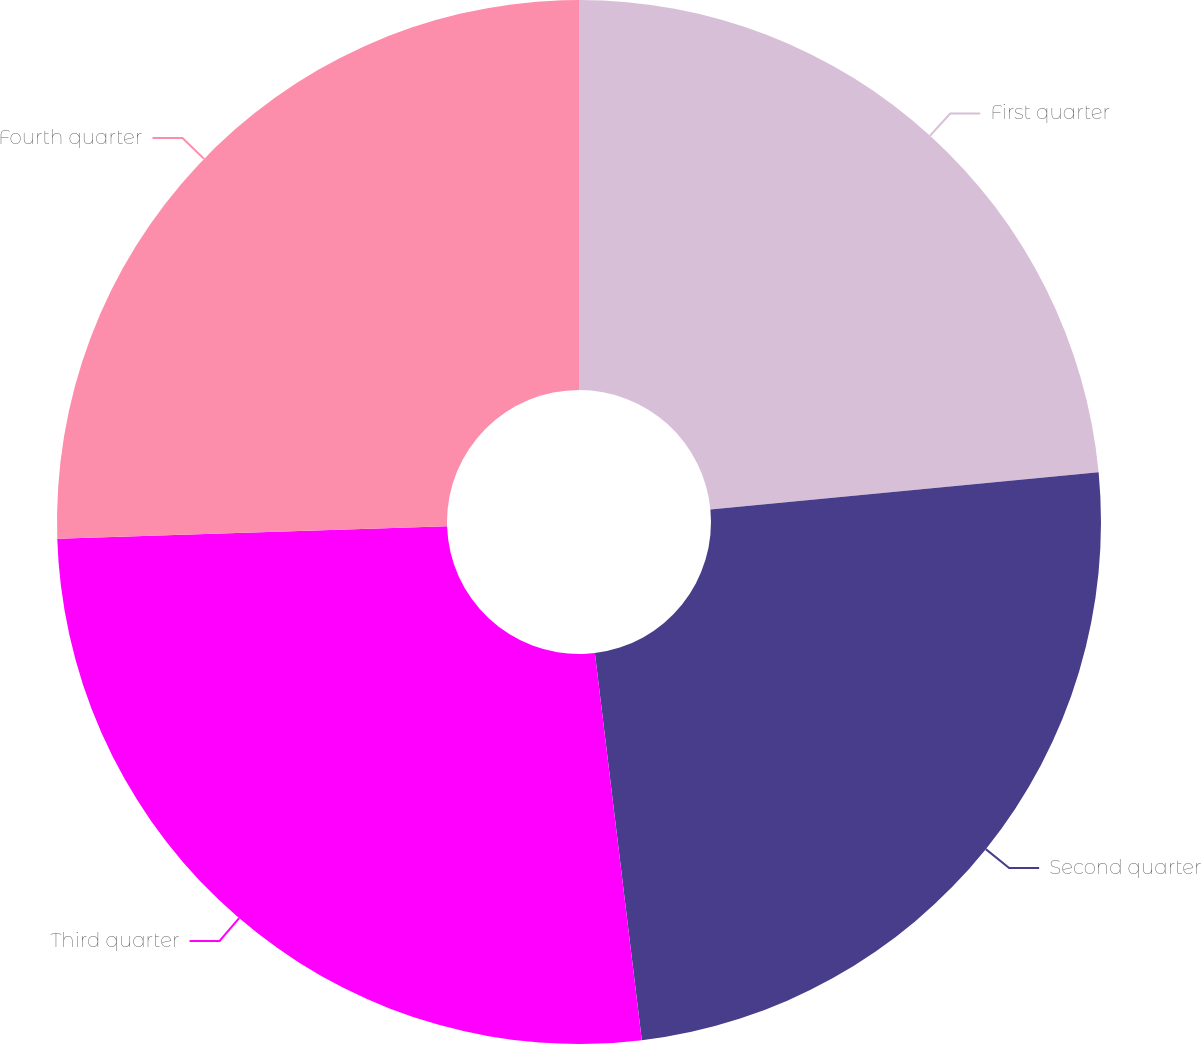Convert chart to OTSL. <chart><loc_0><loc_0><loc_500><loc_500><pie_chart><fcel>First quarter<fcel>Second quarter<fcel>Third quarter<fcel>Fourth quarter<nl><fcel>23.48%<fcel>24.6%<fcel>26.41%<fcel>25.51%<nl></chart> 